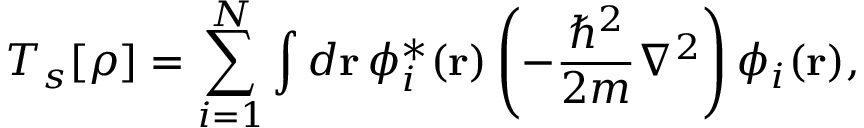<formula> <loc_0><loc_0><loc_500><loc_500>T _ { s } [ \rho ] = \sum _ { i = 1 } ^ { N } \int d r \, \phi _ { i } ^ { * } ( r ) \left ( - { \frac { \hbar { ^ } { 2 } } { 2 m } } \nabla ^ { 2 } \right ) \phi _ { i } ( r ) ,</formula> 